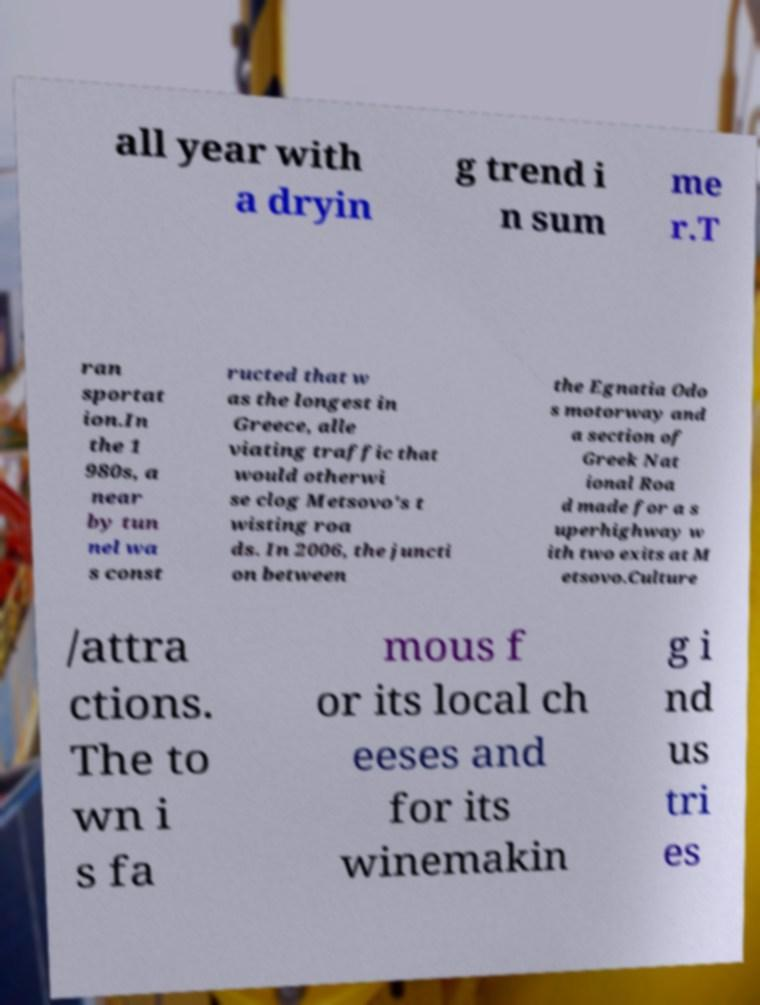For documentation purposes, I need the text within this image transcribed. Could you provide that? all year with a dryin g trend i n sum me r.T ran sportat ion.In the 1 980s, a near by tun nel wa s const ructed that w as the longest in Greece, alle viating traffic that would otherwi se clog Metsovo's t wisting roa ds. In 2006, the juncti on between the Egnatia Odo s motorway and a section of Greek Nat ional Roa d made for a s uperhighway w ith two exits at M etsovo.Culture /attra ctions. The to wn i s fa mous f or its local ch eeses and for its winemakin g i nd us tri es 